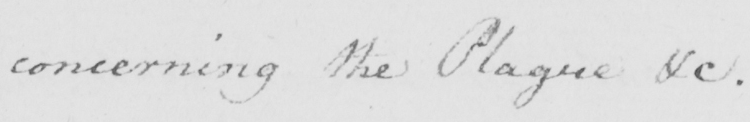What text is written in this handwritten line? concerning the Plague &c . 